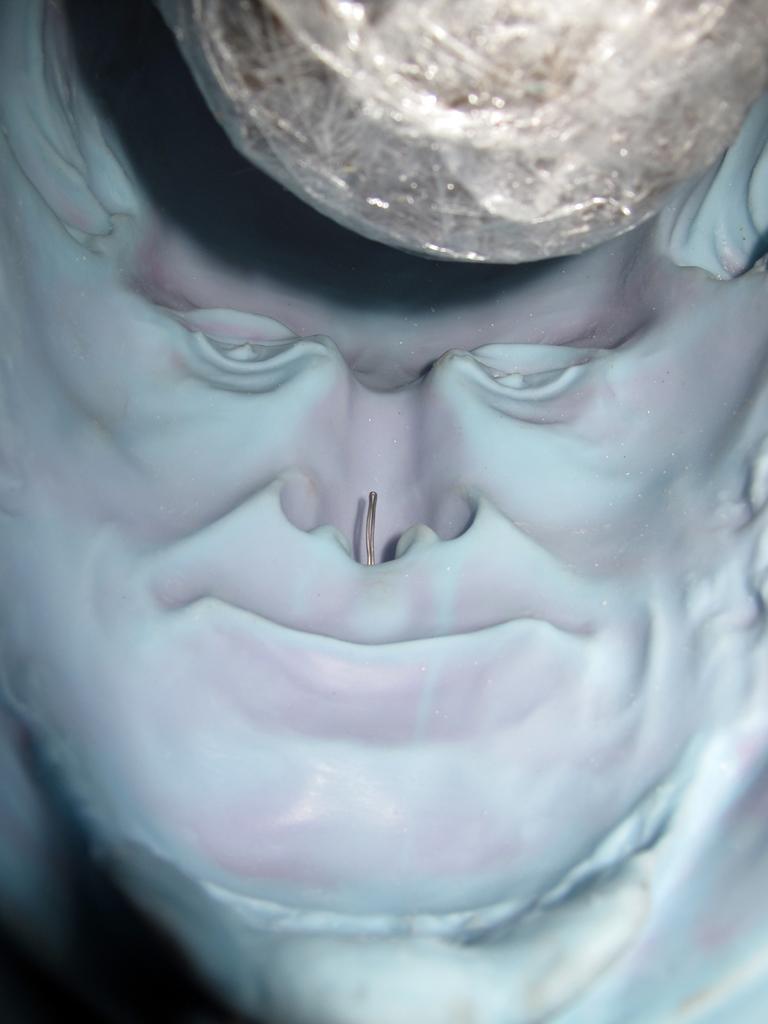Describe this image in one or two sentences. We can see a sculpture of a person face. 